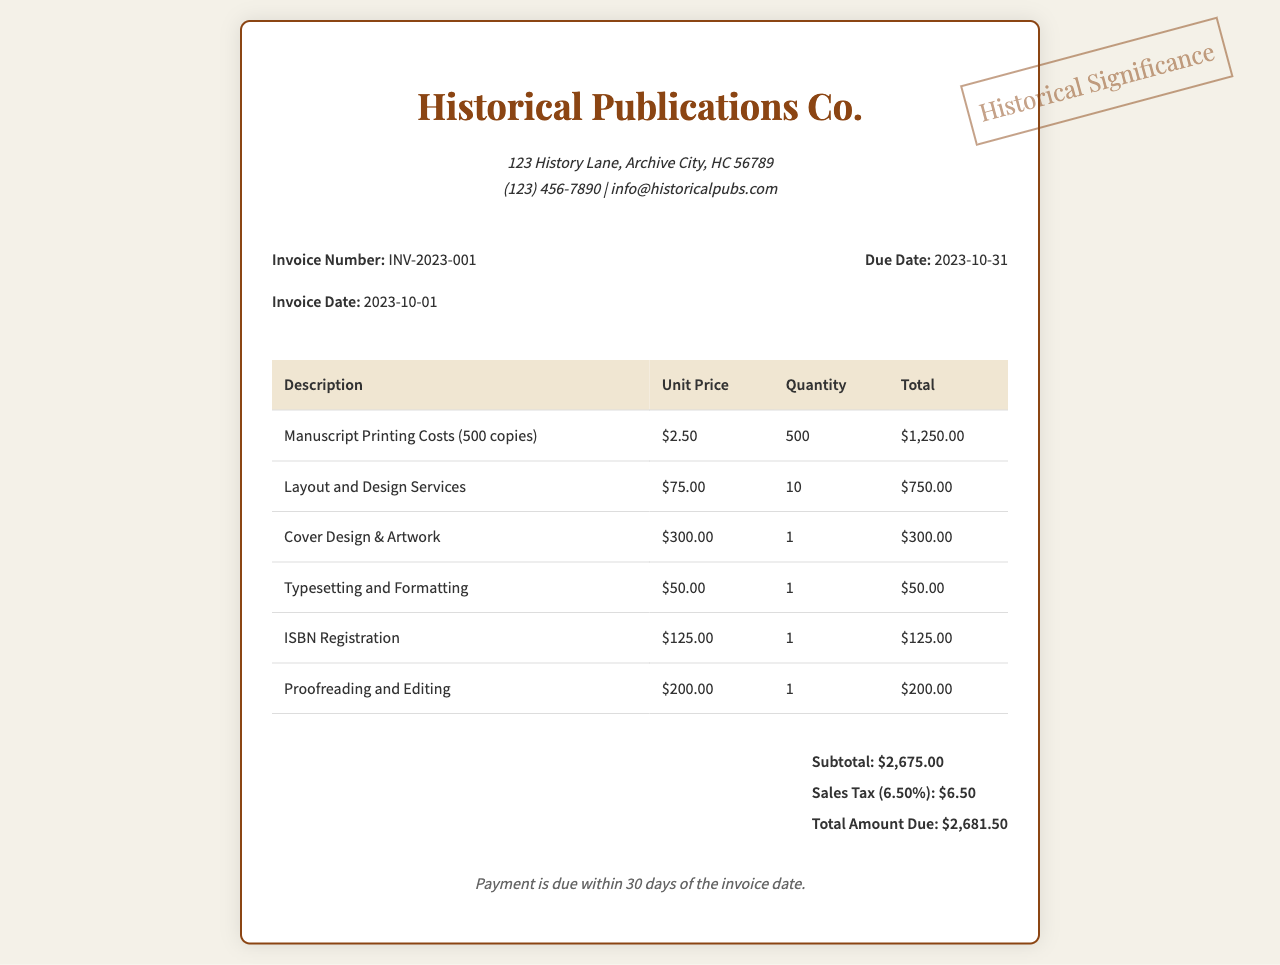What is the invoice number? The invoice number is listed prominently in the document after "Invoice Number:".
Answer: INV-2023-001 What is the due date? The due date is specified as "Due Date:" in the invoice details.
Answer: 2023-10-31 How many copies of the manuscript are being printed? The quantity of manuscript copies is indicated in the "Manuscript Printing Costs" row of the table.
Answer: 500 What is the total amount due? The total amount due is summarized at the end of the invoice.
Answer: $2,681.50 What is the unit price for layout and design services? The unit price for layout and design services can be found in the respective row of the invoice.
Answer: $75.00 What is the subtotal amount listed in the invoice? The subtotal is presented before the sales tax calculation in the invoice.
Answer: $2,675.00 Which service costs the most in total? The total for each service is listed in the table, allowing identification of the highest cost.
Answer: Manuscript Printing Costs What percentage is the sales tax? The sales tax percentage is explicitly stated in the document.
Answer: 6.50% What payment terms are outlined in the invoice? Payment terms can be found at the end of the invoice, detailing the expected payment timeframe.
Answer: Payment is due within 30 days of the invoice date 